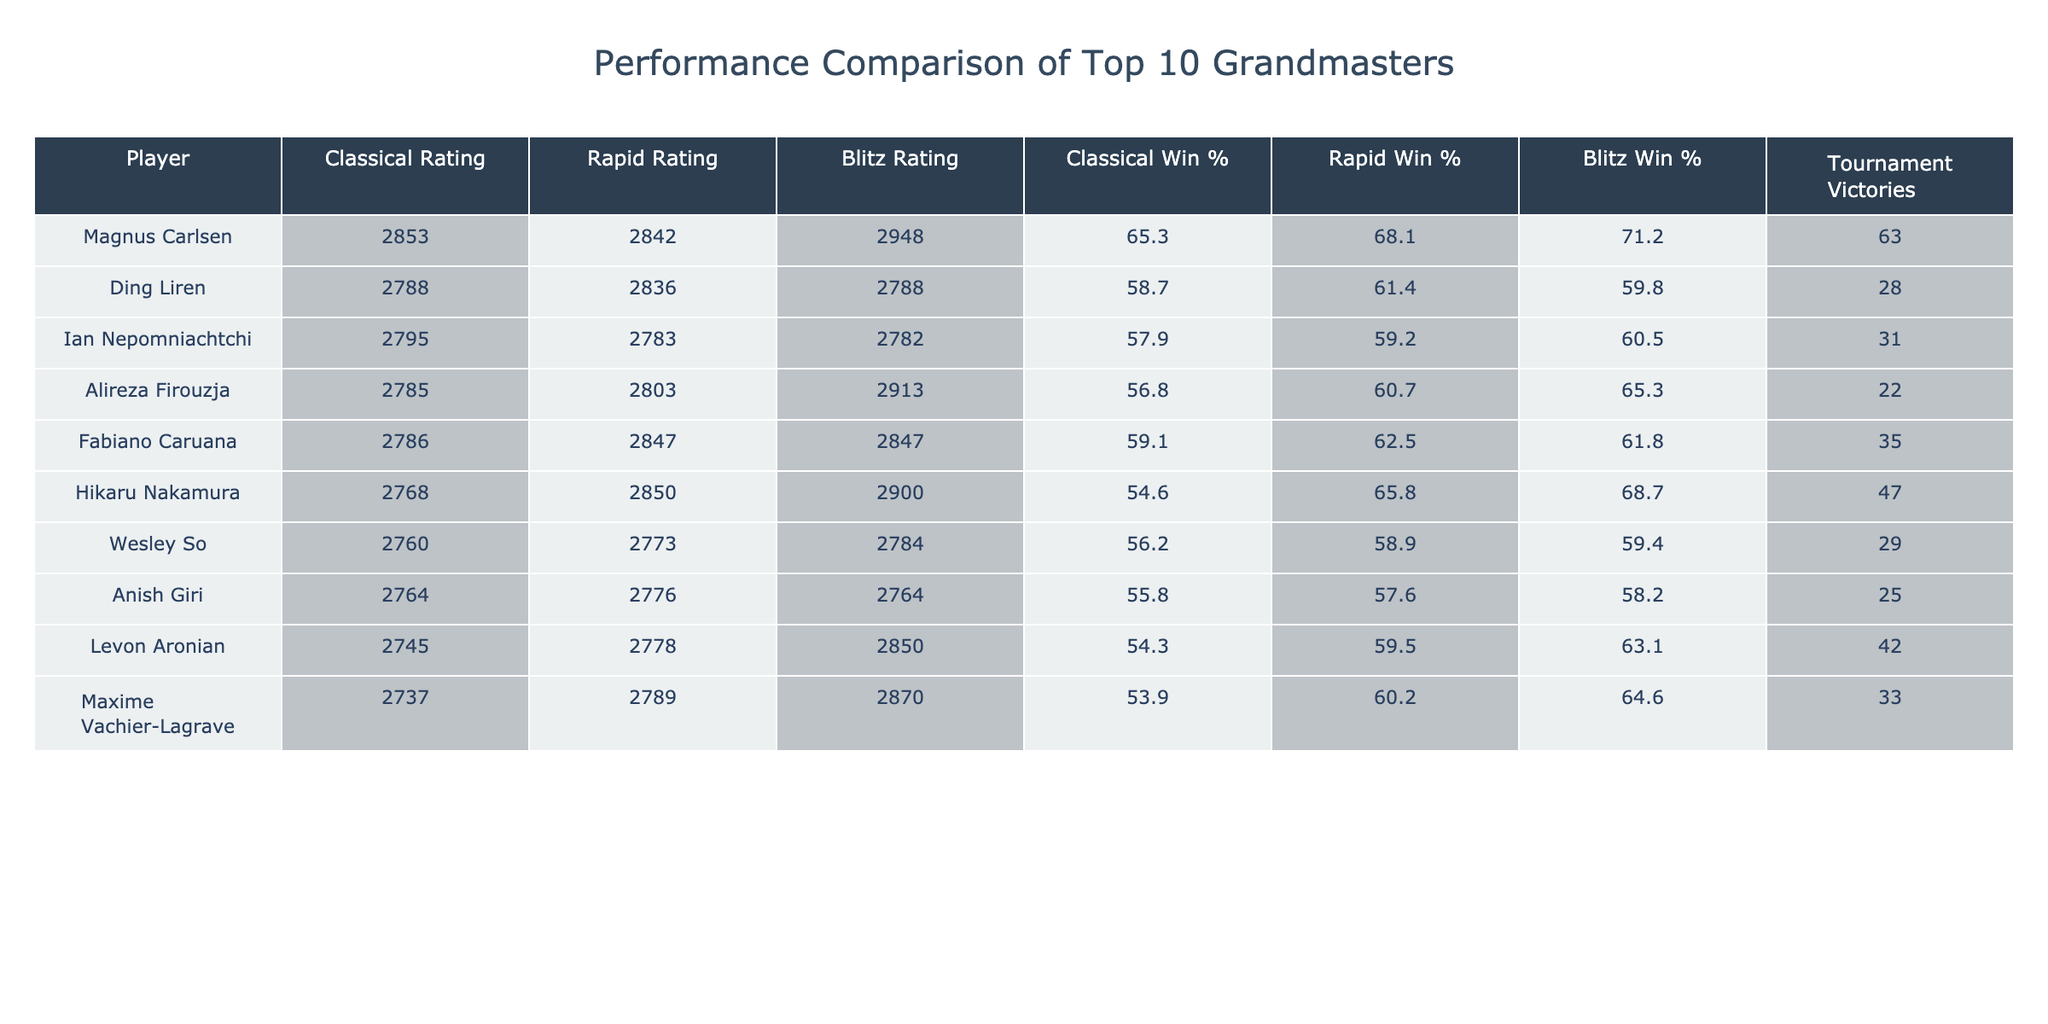What is Magnus Carlsen's Blitz Rating? The table lists Magnus Carlsen's Blitz Rating directly under the "Blitz Rating" column. That value is 2948.
Answer: 2948 Who has the highest Classical Win percentage? By comparing the values in the "Classical Win %" column, Magnus Carlsen has the highest win percentage at 65.3%.
Answer: 65.3% What is the difference in Tournament Victories between Hikaru Nakamura and Ding Liren? The table shows Hikaru Nakamura's tournament victories as 47 and Ding Liren's as 28. To find the difference, subtract 28 from 47, which gives 19.
Answer: 19 Is Alireza Firouzja's Rapid Win percentage higher than Ian Nepomniachtchi's Classical Win percentage? Alireza Firouzja's Rapid Win percentage is 60.7%, while Ian Nepomniachtchi's Classical Win percentage is 57.9%. Since 60.7% is greater than 57.9%, the answer is yes.
Answer: Yes What is the average Blitz Rating of the top three players listed? The top three players are Magnus Carlsen (2948), Alireza Firouzja (2913), and Hikaru Nakamura (2900). Adding these gives 2948 + 2913 + 2900 = 8761. Dividing by 3 gives an average of 2920.33, which rounds to 2920.
Answer: 2920 Which player has the lowest Classical Rating, and what is that value? By examining the "Classical Rating" column, Maxime Vachier-Lagrave has the lowest rating of 2737.
Answer: 2737 Which two players have the same Blitz Rating, and what is that value? Both Ding Liren and Ian Nepomniachtchi have a Blitz Rating of 2788.
Answer: 2788 How many players have a Classical Win percentage greater than 60%? By reviewing the "Classical Win %" column, Magnus Carlsen, Fabiano Caruana, and Ding Liren have percentages above 60% (65.3, 59.1, and 58.7 respectively). So, 3 players exceed this threshold.
Answer: 3 What is the total number of Tournament Victories for the top four players? The top four players are Magnus Carlsen (63), Ding Liren (28), Ian Nepomniachtchi (31), and Alireza Firouzja (22). Adding these gives 63 + 28 + 31 + 22 = 144.
Answer: 144 Is it true that Wesley So has a Blitz Win percentage lower than Maxime Vachier-Lagrave? Wesley So's Blitz Win percentage is 59.4% compared to Maxime Vachier-Lagrave's 64.6%. Since 59.4% is less than 64.6%, the statement is true.
Answer: True 